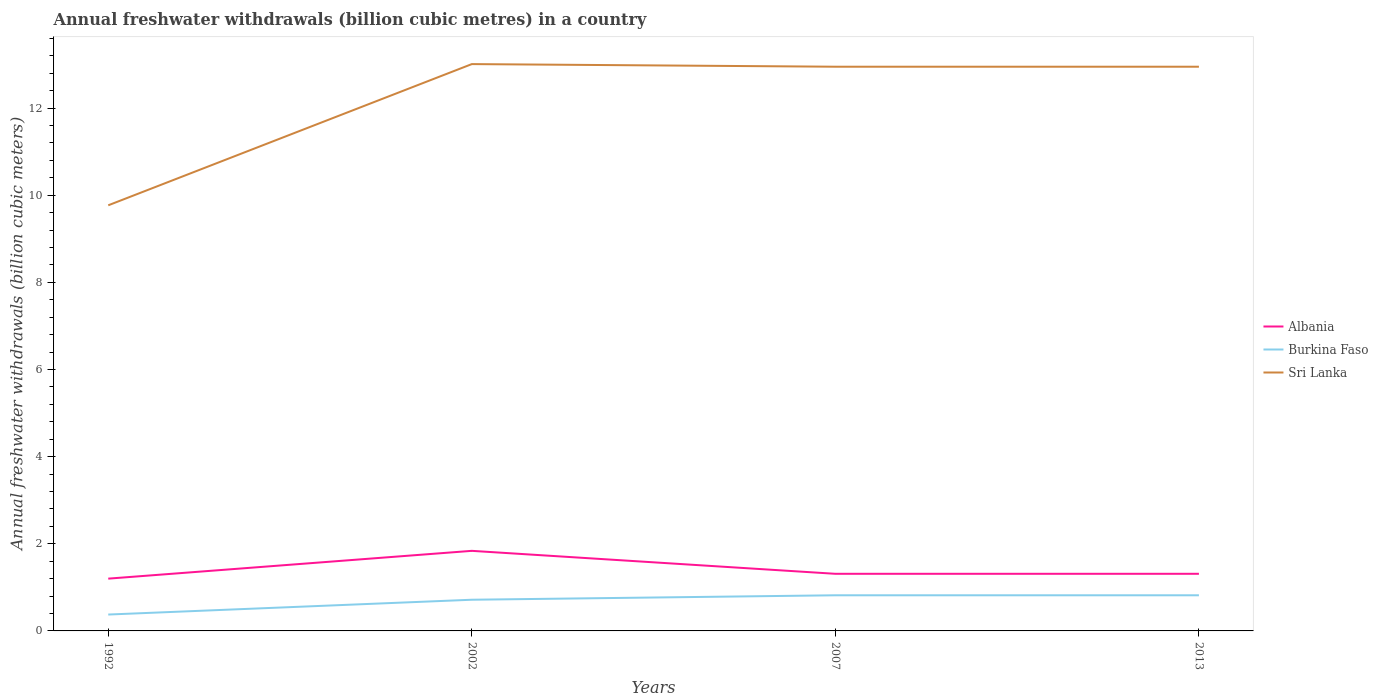How many different coloured lines are there?
Offer a terse response. 3. Across all years, what is the maximum annual freshwater withdrawals in Sri Lanka?
Provide a short and direct response. 9.77. In which year was the annual freshwater withdrawals in Burkina Faso maximum?
Your answer should be very brief. 1992. What is the total annual freshwater withdrawals in Burkina Faso in the graph?
Your answer should be compact. -0.44. What is the difference between the highest and the second highest annual freshwater withdrawals in Albania?
Give a very brief answer. 0.64. What is the difference between the highest and the lowest annual freshwater withdrawals in Albania?
Offer a terse response. 1. Is the annual freshwater withdrawals in Burkina Faso strictly greater than the annual freshwater withdrawals in Albania over the years?
Offer a terse response. Yes. How many lines are there?
Ensure brevity in your answer.  3. Are the values on the major ticks of Y-axis written in scientific E-notation?
Ensure brevity in your answer.  No. Does the graph contain any zero values?
Give a very brief answer. No. Does the graph contain grids?
Give a very brief answer. No. How many legend labels are there?
Your answer should be very brief. 3. What is the title of the graph?
Give a very brief answer. Annual freshwater withdrawals (billion cubic metres) in a country. What is the label or title of the Y-axis?
Ensure brevity in your answer.  Annual freshwater withdrawals (billion cubic meters). What is the Annual freshwater withdrawals (billion cubic meters) of Burkina Faso in 1992?
Make the answer very short. 0.38. What is the Annual freshwater withdrawals (billion cubic meters) in Sri Lanka in 1992?
Offer a very short reply. 9.77. What is the Annual freshwater withdrawals (billion cubic meters) in Albania in 2002?
Offer a very short reply. 1.84. What is the Annual freshwater withdrawals (billion cubic meters) of Burkina Faso in 2002?
Your response must be concise. 0.72. What is the Annual freshwater withdrawals (billion cubic meters) in Sri Lanka in 2002?
Make the answer very short. 13.01. What is the Annual freshwater withdrawals (billion cubic meters) in Albania in 2007?
Give a very brief answer. 1.31. What is the Annual freshwater withdrawals (billion cubic meters) of Burkina Faso in 2007?
Make the answer very short. 0.82. What is the Annual freshwater withdrawals (billion cubic meters) in Sri Lanka in 2007?
Offer a very short reply. 12.95. What is the Annual freshwater withdrawals (billion cubic meters) in Albania in 2013?
Ensure brevity in your answer.  1.31. What is the Annual freshwater withdrawals (billion cubic meters) in Burkina Faso in 2013?
Your answer should be compact. 0.82. What is the Annual freshwater withdrawals (billion cubic meters) of Sri Lanka in 2013?
Offer a terse response. 12.95. Across all years, what is the maximum Annual freshwater withdrawals (billion cubic meters) in Albania?
Ensure brevity in your answer.  1.84. Across all years, what is the maximum Annual freshwater withdrawals (billion cubic meters) in Burkina Faso?
Your answer should be very brief. 0.82. Across all years, what is the maximum Annual freshwater withdrawals (billion cubic meters) of Sri Lanka?
Provide a short and direct response. 13.01. Across all years, what is the minimum Annual freshwater withdrawals (billion cubic meters) of Burkina Faso?
Your answer should be compact. 0.38. Across all years, what is the minimum Annual freshwater withdrawals (billion cubic meters) in Sri Lanka?
Give a very brief answer. 9.77. What is the total Annual freshwater withdrawals (billion cubic meters) of Albania in the graph?
Offer a very short reply. 5.66. What is the total Annual freshwater withdrawals (billion cubic meters) of Burkina Faso in the graph?
Ensure brevity in your answer.  2.73. What is the total Annual freshwater withdrawals (billion cubic meters) in Sri Lanka in the graph?
Offer a very short reply. 48.68. What is the difference between the Annual freshwater withdrawals (billion cubic meters) in Albania in 1992 and that in 2002?
Keep it short and to the point. -0.64. What is the difference between the Annual freshwater withdrawals (billion cubic meters) of Burkina Faso in 1992 and that in 2002?
Your answer should be very brief. -0.34. What is the difference between the Annual freshwater withdrawals (billion cubic meters) in Sri Lanka in 1992 and that in 2002?
Your answer should be very brief. -3.24. What is the difference between the Annual freshwater withdrawals (billion cubic meters) of Albania in 1992 and that in 2007?
Your answer should be compact. -0.11. What is the difference between the Annual freshwater withdrawals (billion cubic meters) of Burkina Faso in 1992 and that in 2007?
Your response must be concise. -0.44. What is the difference between the Annual freshwater withdrawals (billion cubic meters) in Sri Lanka in 1992 and that in 2007?
Offer a terse response. -3.18. What is the difference between the Annual freshwater withdrawals (billion cubic meters) of Albania in 1992 and that in 2013?
Provide a succinct answer. -0.11. What is the difference between the Annual freshwater withdrawals (billion cubic meters) in Burkina Faso in 1992 and that in 2013?
Offer a terse response. -0.44. What is the difference between the Annual freshwater withdrawals (billion cubic meters) of Sri Lanka in 1992 and that in 2013?
Ensure brevity in your answer.  -3.18. What is the difference between the Annual freshwater withdrawals (billion cubic meters) in Albania in 2002 and that in 2007?
Offer a very short reply. 0.53. What is the difference between the Annual freshwater withdrawals (billion cubic meters) in Burkina Faso in 2002 and that in 2007?
Your response must be concise. -0.1. What is the difference between the Annual freshwater withdrawals (billion cubic meters) in Sri Lanka in 2002 and that in 2007?
Provide a short and direct response. 0.06. What is the difference between the Annual freshwater withdrawals (billion cubic meters) in Albania in 2002 and that in 2013?
Offer a terse response. 0.53. What is the difference between the Annual freshwater withdrawals (billion cubic meters) of Burkina Faso in 2002 and that in 2013?
Your answer should be compact. -0.1. What is the difference between the Annual freshwater withdrawals (billion cubic meters) of Albania in 2007 and that in 2013?
Your answer should be very brief. 0. What is the difference between the Annual freshwater withdrawals (billion cubic meters) of Sri Lanka in 2007 and that in 2013?
Provide a short and direct response. 0. What is the difference between the Annual freshwater withdrawals (billion cubic meters) of Albania in 1992 and the Annual freshwater withdrawals (billion cubic meters) of Burkina Faso in 2002?
Your response must be concise. 0.48. What is the difference between the Annual freshwater withdrawals (billion cubic meters) in Albania in 1992 and the Annual freshwater withdrawals (billion cubic meters) in Sri Lanka in 2002?
Provide a succinct answer. -11.81. What is the difference between the Annual freshwater withdrawals (billion cubic meters) in Burkina Faso in 1992 and the Annual freshwater withdrawals (billion cubic meters) in Sri Lanka in 2002?
Your answer should be very brief. -12.63. What is the difference between the Annual freshwater withdrawals (billion cubic meters) in Albania in 1992 and the Annual freshwater withdrawals (billion cubic meters) in Burkina Faso in 2007?
Your answer should be very brief. 0.38. What is the difference between the Annual freshwater withdrawals (billion cubic meters) of Albania in 1992 and the Annual freshwater withdrawals (billion cubic meters) of Sri Lanka in 2007?
Ensure brevity in your answer.  -11.75. What is the difference between the Annual freshwater withdrawals (billion cubic meters) of Burkina Faso in 1992 and the Annual freshwater withdrawals (billion cubic meters) of Sri Lanka in 2007?
Your answer should be very brief. -12.57. What is the difference between the Annual freshwater withdrawals (billion cubic meters) of Albania in 1992 and the Annual freshwater withdrawals (billion cubic meters) of Burkina Faso in 2013?
Your answer should be very brief. 0.38. What is the difference between the Annual freshwater withdrawals (billion cubic meters) of Albania in 1992 and the Annual freshwater withdrawals (billion cubic meters) of Sri Lanka in 2013?
Your answer should be very brief. -11.75. What is the difference between the Annual freshwater withdrawals (billion cubic meters) in Burkina Faso in 1992 and the Annual freshwater withdrawals (billion cubic meters) in Sri Lanka in 2013?
Provide a succinct answer. -12.57. What is the difference between the Annual freshwater withdrawals (billion cubic meters) in Albania in 2002 and the Annual freshwater withdrawals (billion cubic meters) in Burkina Faso in 2007?
Your response must be concise. 1.02. What is the difference between the Annual freshwater withdrawals (billion cubic meters) in Albania in 2002 and the Annual freshwater withdrawals (billion cubic meters) in Sri Lanka in 2007?
Ensure brevity in your answer.  -11.11. What is the difference between the Annual freshwater withdrawals (billion cubic meters) in Burkina Faso in 2002 and the Annual freshwater withdrawals (billion cubic meters) in Sri Lanka in 2007?
Keep it short and to the point. -12.23. What is the difference between the Annual freshwater withdrawals (billion cubic meters) in Albania in 2002 and the Annual freshwater withdrawals (billion cubic meters) in Burkina Faso in 2013?
Offer a terse response. 1.02. What is the difference between the Annual freshwater withdrawals (billion cubic meters) of Albania in 2002 and the Annual freshwater withdrawals (billion cubic meters) of Sri Lanka in 2013?
Ensure brevity in your answer.  -11.11. What is the difference between the Annual freshwater withdrawals (billion cubic meters) of Burkina Faso in 2002 and the Annual freshwater withdrawals (billion cubic meters) of Sri Lanka in 2013?
Your response must be concise. -12.23. What is the difference between the Annual freshwater withdrawals (billion cubic meters) in Albania in 2007 and the Annual freshwater withdrawals (billion cubic meters) in Burkina Faso in 2013?
Offer a terse response. 0.49. What is the difference between the Annual freshwater withdrawals (billion cubic meters) in Albania in 2007 and the Annual freshwater withdrawals (billion cubic meters) in Sri Lanka in 2013?
Make the answer very short. -11.64. What is the difference between the Annual freshwater withdrawals (billion cubic meters) of Burkina Faso in 2007 and the Annual freshwater withdrawals (billion cubic meters) of Sri Lanka in 2013?
Offer a very short reply. -12.13. What is the average Annual freshwater withdrawals (billion cubic meters) of Albania per year?
Your response must be concise. 1.42. What is the average Annual freshwater withdrawals (billion cubic meters) in Burkina Faso per year?
Keep it short and to the point. 0.68. What is the average Annual freshwater withdrawals (billion cubic meters) in Sri Lanka per year?
Your answer should be compact. 12.17. In the year 1992, what is the difference between the Annual freshwater withdrawals (billion cubic meters) in Albania and Annual freshwater withdrawals (billion cubic meters) in Burkina Faso?
Ensure brevity in your answer.  0.82. In the year 1992, what is the difference between the Annual freshwater withdrawals (billion cubic meters) in Albania and Annual freshwater withdrawals (billion cubic meters) in Sri Lanka?
Ensure brevity in your answer.  -8.57. In the year 1992, what is the difference between the Annual freshwater withdrawals (billion cubic meters) of Burkina Faso and Annual freshwater withdrawals (billion cubic meters) of Sri Lanka?
Offer a terse response. -9.39. In the year 2002, what is the difference between the Annual freshwater withdrawals (billion cubic meters) of Albania and Annual freshwater withdrawals (billion cubic meters) of Burkina Faso?
Ensure brevity in your answer.  1.12. In the year 2002, what is the difference between the Annual freshwater withdrawals (billion cubic meters) in Albania and Annual freshwater withdrawals (billion cubic meters) in Sri Lanka?
Provide a short and direct response. -11.17. In the year 2002, what is the difference between the Annual freshwater withdrawals (billion cubic meters) of Burkina Faso and Annual freshwater withdrawals (billion cubic meters) of Sri Lanka?
Provide a short and direct response. -12.29. In the year 2007, what is the difference between the Annual freshwater withdrawals (billion cubic meters) in Albania and Annual freshwater withdrawals (billion cubic meters) in Burkina Faso?
Offer a very short reply. 0.49. In the year 2007, what is the difference between the Annual freshwater withdrawals (billion cubic meters) in Albania and Annual freshwater withdrawals (billion cubic meters) in Sri Lanka?
Make the answer very short. -11.64. In the year 2007, what is the difference between the Annual freshwater withdrawals (billion cubic meters) in Burkina Faso and Annual freshwater withdrawals (billion cubic meters) in Sri Lanka?
Provide a succinct answer. -12.13. In the year 2013, what is the difference between the Annual freshwater withdrawals (billion cubic meters) of Albania and Annual freshwater withdrawals (billion cubic meters) of Burkina Faso?
Offer a terse response. 0.49. In the year 2013, what is the difference between the Annual freshwater withdrawals (billion cubic meters) of Albania and Annual freshwater withdrawals (billion cubic meters) of Sri Lanka?
Give a very brief answer. -11.64. In the year 2013, what is the difference between the Annual freshwater withdrawals (billion cubic meters) of Burkina Faso and Annual freshwater withdrawals (billion cubic meters) of Sri Lanka?
Ensure brevity in your answer.  -12.13. What is the ratio of the Annual freshwater withdrawals (billion cubic meters) of Albania in 1992 to that in 2002?
Your answer should be compact. 0.65. What is the ratio of the Annual freshwater withdrawals (billion cubic meters) in Burkina Faso in 1992 to that in 2002?
Provide a succinct answer. 0.53. What is the ratio of the Annual freshwater withdrawals (billion cubic meters) of Sri Lanka in 1992 to that in 2002?
Offer a very short reply. 0.75. What is the ratio of the Annual freshwater withdrawals (billion cubic meters) in Albania in 1992 to that in 2007?
Keep it short and to the point. 0.92. What is the ratio of the Annual freshwater withdrawals (billion cubic meters) in Burkina Faso in 1992 to that in 2007?
Make the answer very short. 0.46. What is the ratio of the Annual freshwater withdrawals (billion cubic meters) in Sri Lanka in 1992 to that in 2007?
Keep it short and to the point. 0.75. What is the ratio of the Annual freshwater withdrawals (billion cubic meters) of Albania in 1992 to that in 2013?
Give a very brief answer. 0.92. What is the ratio of the Annual freshwater withdrawals (billion cubic meters) of Burkina Faso in 1992 to that in 2013?
Keep it short and to the point. 0.46. What is the ratio of the Annual freshwater withdrawals (billion cubic meters) in Sri Lanka in 1992 to that in 2013?
Your answer should be compact. 0.75. What is the ratio of the Annual freshwater withdrawals (billion cubic meters) in Albania in 2002 to that in 2007?
Provide a succinct answer. 1.4. What is the ratio of the Annual freshwater withdrawals (billion cubic meters) in Burkina Faso in 2002 to that in 2007?
Provide a succinct answer. 0.87. What is the ratio of the Annual freshwater withdrawals (billion cubic meters) in Albania in 2002 to that in 2013?
Your answer should be very brief. 1.4. What is the ratio of the Annual freshwater withdrawals (billion cubic meters) in Burkina Faso in 2002 to that in 2013?
Your answer should be very brief. 0.87. What is the ratio of the Annual freshwater withdrawals (billion cubic meters) in Sri Lanka in 2002 to that in 2013?
Your response must be concise. 1. What is the ratio of the Annual freshwater withdrawals (billion cubic meters) of Albania in 2007 to that in 2013?
Provide a succinct answer. 1. What is the difference between the highest and the second highest Annual freshwater withdrawals (billion cubic meters) in Albania?
Provide a short and direct response. 0.53. What is the difference between the highest and the second highest Annual freshwater withdrawals (billion cubic meters) in Burkina Faso?
Offer a terse response. 0. What is the difference between the highest and the second highest Annual freshwater withdrawals (billion cubic meters) of Sri Lanka?
Ensure brevity in your answer.  0.06. What is the difference between the highest and the lowest Annual freshwater withdrawals (billion cubic meters) in Albania?
Keep it short and to the point. 0.64. What is the difference between the highest and the lowest Annual freshwater withdrawals (billion cubic meters) of Burkina Faso?
Offer a very short reply. 0.44. What is the difference between the highest and the lowest Annual freshwater withdrawals (billion cubic meters) of Sri Lanka?
Provide a short and direct response. 3.24. 